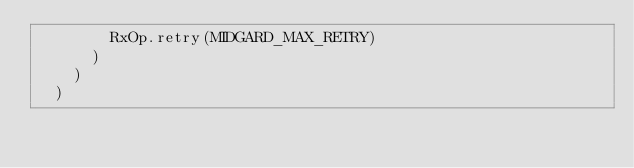Convert code to text. <code><loc_0><loc_0><loc_500><loc_500><_TypeScript_>        RxOp.retry(MIDGARD_MAX_RETRY)
      )
    )
  )
</code> 